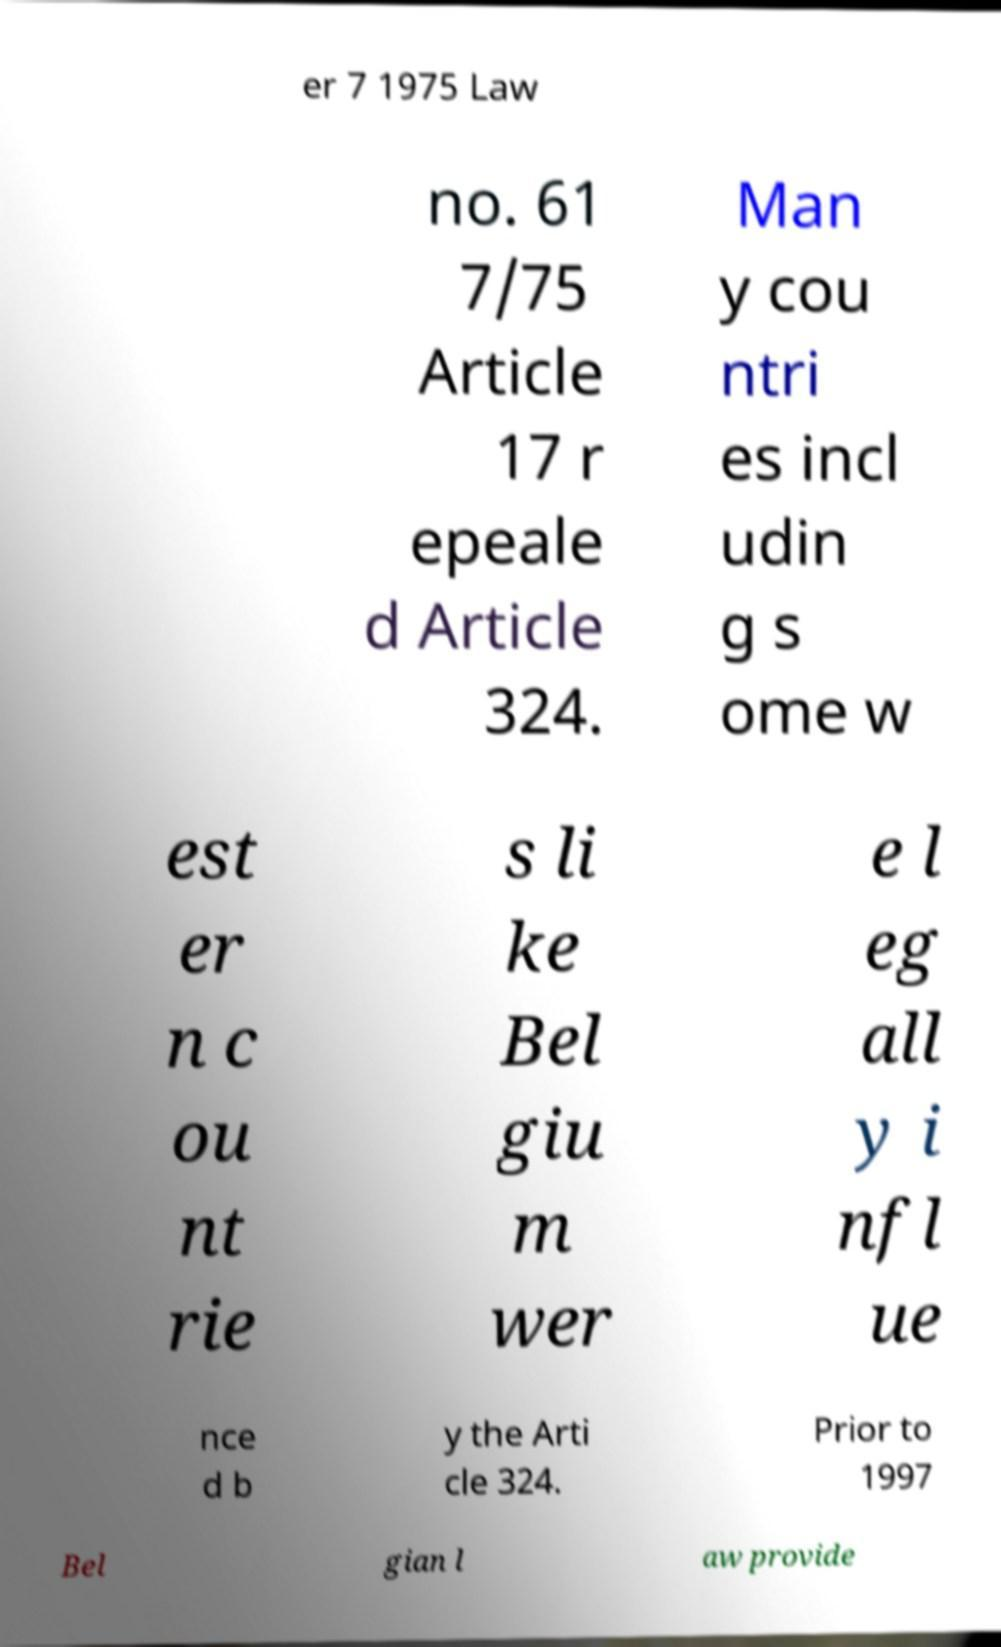What messages or text are displayed in this image? I need them in a readable, typed format. er 7 1975 Law no. 61 7/75 Article 17 r epeale d Article 324. Man y cou ntri es incl udin g s ome w est er n c ou nt rie s li ke Bel giu m wer e l eg all y i nfl ue nce d b y the Arti cle 324. Prior to 1997 Bel gian l aw provide 